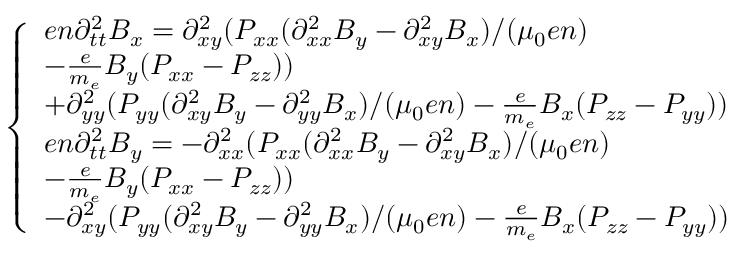Convert formula to latex. <formula><loc_0><loc_0><loc_500><loc_500>\begin{array} { r } { \left \{ \begin{array} { l l } { e n \partial _ { t t } ^ { 2 } B _ { x } = \partial _ { x y } ^ { 2 } ( P _ { x x } ( \partial _ { x x } ^ { 2 } B _ { y } - \partial _ { x y } ^ { 2 } B _ { x } ) / ( \mu _ { 0 } e n ) } \\ { - \frac { e } { m _ { e } } B _ { y } ( P _ { x x } - P _ { z z } ) ) } \\ { + \partial _ { y y } ^ { 2 } ( P _ { y y } ( \partial _ { x y } ^ { 2 } B _ { y } - \partial _ { y y } ^ { 2 } B _ { x } ) / ( \mu _ { 0 } e n ) - \frac { e } { m _ { e } } B _ { x } ( P _ { z z } - P _ { y y } ) ) } \\ { e n \partial _ { t t } ^ { 2 } B _ { y } = - \partial _ { x x } ^ { 2 } ( P _ { x x } ( \partial _ { x x } ^ { 2 } B _ { y } - \partial _ { x y } ^ { 2 } B _ { x } ) / ( \mu _ { 0 } e n ) } \\ { - \frac { e } { m _ { e } } B _ { y } ( P _ { x x } - P _ { z z } ) ) } \\ { - \partial _ { x y } ^ { 2 } ( P _ { y y } ( \partial _ { x y } ^ { 2 } B _ { y } - \partial _ { y y } ^ { 2 } B _ { x } ) / ( \mu _ { 0 } e n ) - \frac { e } { m _ { e } } B _ { x } ( P _ { z z } - P _ { y y } ) ) } \end{array} } \end{array}</formula> 